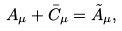<formula> <loc_0><loc_0><loc_500><loc_500>A _ { \mu } + \bar { C } _ { \mu } = \tilde { A } _ { \mu } ,</formula> 